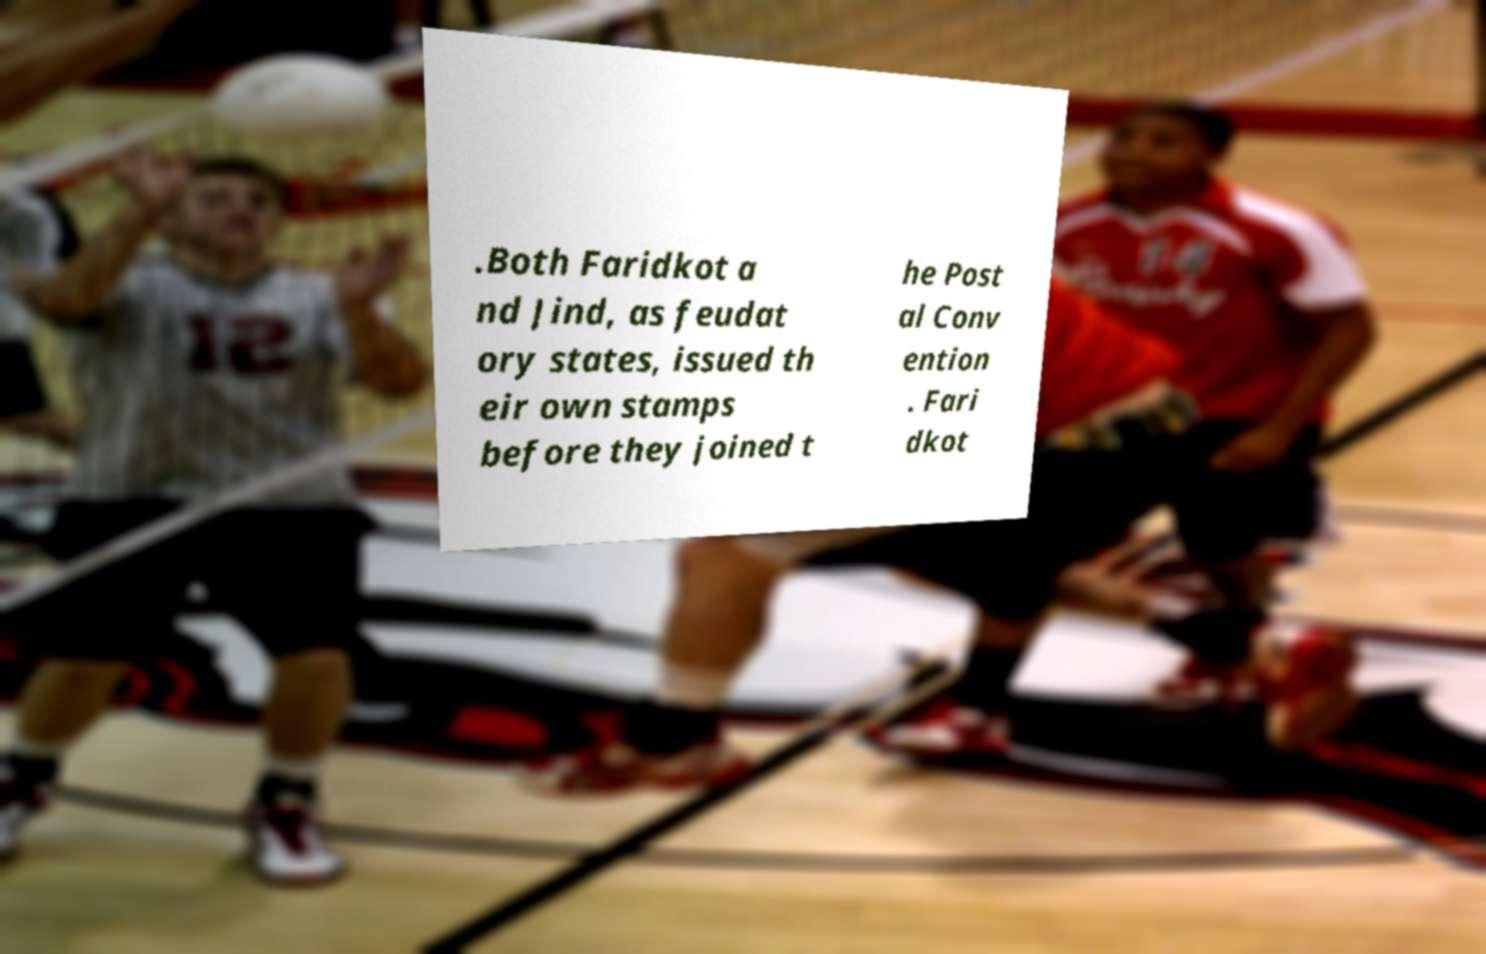Could you assist in decoding the text presented in this image and type it out clearly? .Both Faridkot a nd Jind, as feudat ory states, issued th eir own stamps before they joined t he Post al Conv ention . Fari dkot 